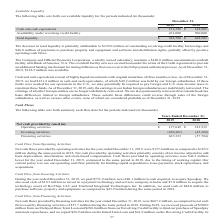According to Aci Worldwide's financial document, What was the net cash from operating activities in 2018? According to the financial document, $183,932 (in thousands). The relevant text states: "Operating activities $ 137,649 $ 183,932..." Also, What was the net cash from operating activities in 2019? According to the financial document, $137,649 (in thousands). The relevant text states: "Operating activities $ 137,649 $ 183,932..." Also, What was the net cash used in investing activities in 2019? Based on the financial document, the answer is -830,481 (in thousands). Also, can you calculate: What was the change in net cash from operating activities between 2018 and 2019? Based on the calculation: $183,932-$137,649, the result is 46283 (in thousands). This is based on the information: "Operating activities $ 137,649 $ 183,932 Operating activities $ 137,649 $ 183,932..." The key data points involved are: 137,649, 183,932. Also, can you calculate: What was the change in net cash used in investing activities between 2018 and 2019? Based on the calculation: -830,481+45,360, the result is -785121 (in thousands). This is based on the information: "Investing activities (830,481 ) (45,360 ) Investing activities (830,481 ) (45,360 )..." The key data points involved are: 45,360, 830,481. Also, can you calculate: What was the percentage change in net cash from financing activities between 2018 and 2019? To answer this question, I need to perform calculations using the financial data. The calculation is: (667,223+57,704)/57,704, which equals 1256.29 (percentage). This is based on the information: "Financing activities 667,223 (57,704 ) Financing activities 667,223 (57,704 )..." The key data points involved are: 57,704, 667,223. 